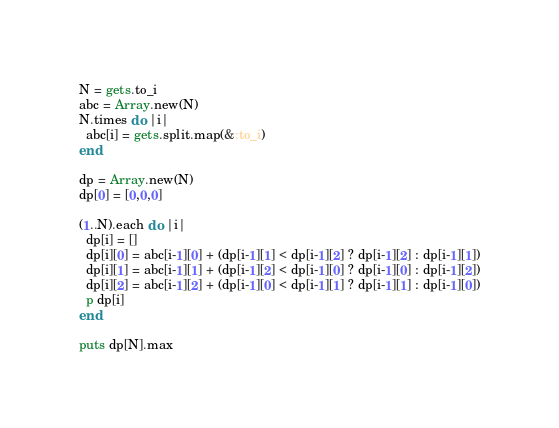Convert code to text. <code><loc_0><loc_0><loc_500><loc_500><_Ruby_>N = gets.to_i
abc = Array.new(N)
N.times do |i|
  abc[i] = gets.split.map(&:to_i)
end

dp = Array.new(N)
dp[0] = [0,0,0]

(1..N).each do |i|
  dp[i] = []
  dp[i][0] = abc[i-1][0] + (dp[i-1][1] < dp[i-1][2] ? dp[i-1][2] : dp[i-1][1])
  dp[i][1] = abc[i-1][1] + (dp[i-1][2] < dp[i-1][0] ? dp[i-1][0] : dp[i-1][2])
  dp[i][2] = abc[i-1][2] + (dp[i-1][0] < dp[i-1][1] ? dp[i-1][1] : dp[i-1][0])
  p dp[i]
end

puts dp[N].max
</code> 